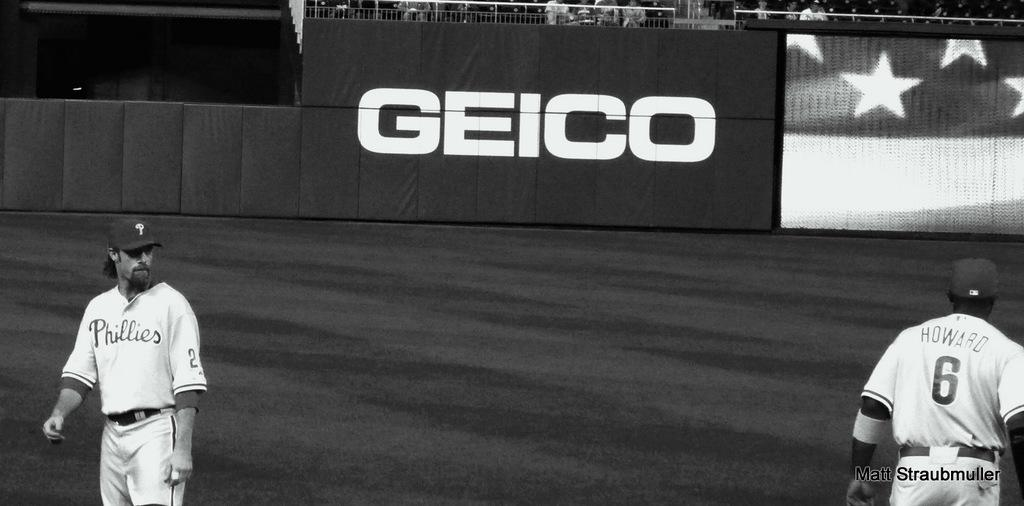Provide a one-sentence caption for the provided image. Two baseball players exchange glances, one with the number 6 on his back, and the other with the word "phillies" written across his chest. 